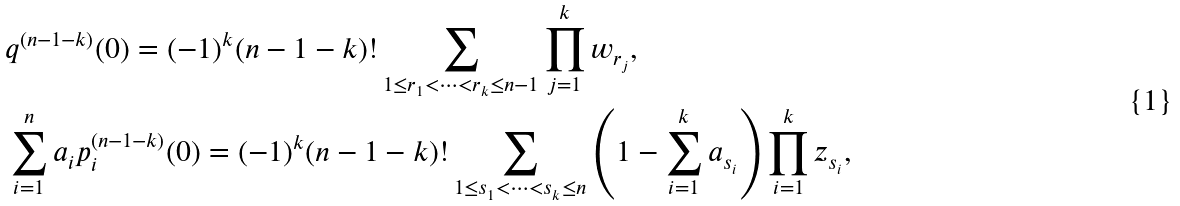Convert formula to latex. <formula><loc_0><loc_0><loc_500><loc_500>& q ^ { ( n - 1 - k ) } ( 0 ) = ( - 1 ) ^ { k } ( n - 1 - k ) ! \sum _ { 1 \leq r _ { 1 } < \dots < r _ { k } \leq n - 1 } \prod _ { j = 1 } ^ { k } w _ { r _ { j } } , \\ & \sum _ { i = 1 } ^ { n } a _ { i } p _ { i } ^ { ( n - 1 - k ) } ( 0 ) = ( - 1 ) ^ { k } ( n - 1 - k ) ! \sum _ { 1 \leq s _ { 1 } < \dots < s _ { k } \leq n } \left ( 1 - \sum _ { i = 1 } ^ { k } a _ { s _ { i } } \right ) \prod _ { i = 1 } ^ { k } z _ { s _ { i } } ,</formula> 